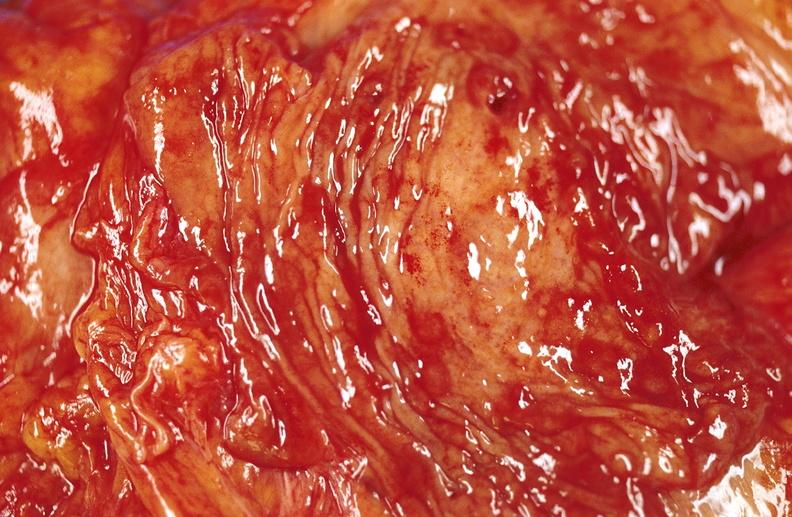where does this belong to?
Answer the question using a single word or phrase. Gastrointestinal system 